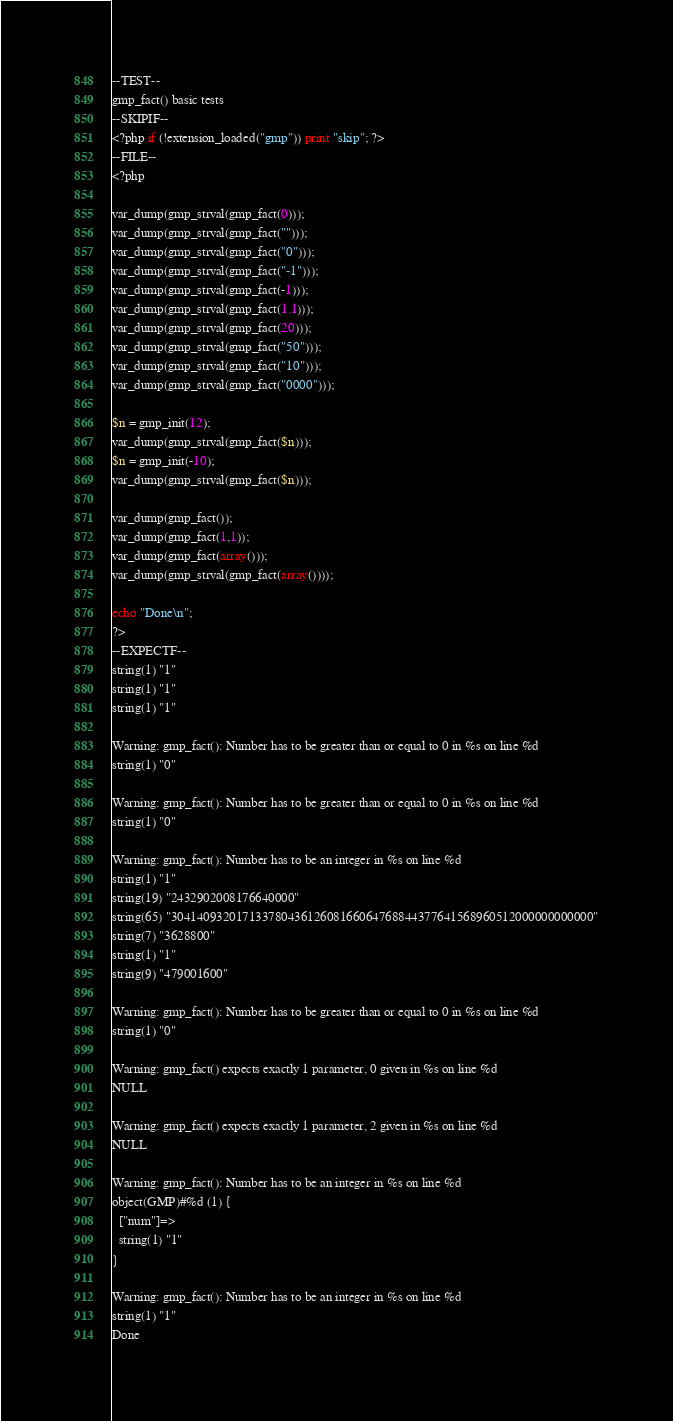<code> <loc_0><loc_0><loc_500><loc_500><_PHP_>--TEST--
gmp_fact() basic tests
--SKIPIF--
<?php if (!extension_loaded("gmp")) print "skip"; ?>
--FILE--
<?php

var_dump(gmp_strval(gmp_fact(0)));
var_dump(gmp_strval(gmp_fact("")));
var_dump(gmp_strval(gmp_fact("0")));
var_dump(gmp_strval(gmp_fact("-1")));
var_dump(gmp_strval(gmp_fact(-1)));
var_dump(gmp_strval(gmp_fact(1.1)));
var_dump(gmp_strval(gmp_fact(20)));
var_dump(gmp_strval(gmp_fact("50")));
var_dump(gmp_strval(gmp_fact("10")));
var_dump(gmp_strval(gmp_fact("0000")));

$n = gmp_init(12);
var_dump(gmp_strval(gmp_fact($n)));
$n = gmp_init(-10);
var_dump(gmp_strval(gmp_fact($n)));

var_dump(gmp_fact());
var_dump(gmp_fact(1,1));
var_dump(gmp_fact(array()));
var_dump(gmp_strval(gmp_fact(array())));

echo "Done\n";
?>
--EXPECTF--
string(1) "1"
string(1) "1"
string(1) "1"

Warning: gmp_fact(): Number has to be greater than or equal to 0 in %s on line %d
string(1) "0"

Warning: gmp_fact(): Number has to be greater than or equal to 0 in %s on line %d
string(1) "0"

Warning: gmp_fact(): Number has to be an integer in %s on line %d
string(1) "1"
string(19) "2432902008176640000"
string(65) "30414093201713378043612608166064768844377641568960512000000000000"
string(7) "3628800"
string(1) "1"
string(9) "479001600"

Warning: gmp_fact(): Number has to be greater than or equal to 0 in %s on line %d
string(1) "0"

Warning: gmp_fact() expects exactly 1 parameter, 0 given in %s on line %d
NULL

Warning: gmp_fact() expects exactly 1 parameter, 2 given in %s on line %d
NULL

Warning: gmp_fact(): Number has to be an integer in %s on line %d
object(GMP)#%d (1) {
  ["num"]=>
  string(1) "1"
}

Warning: gmp_fact(): Number has to be an integer in %s on line %d
string(1) "1"
Done
</code> 